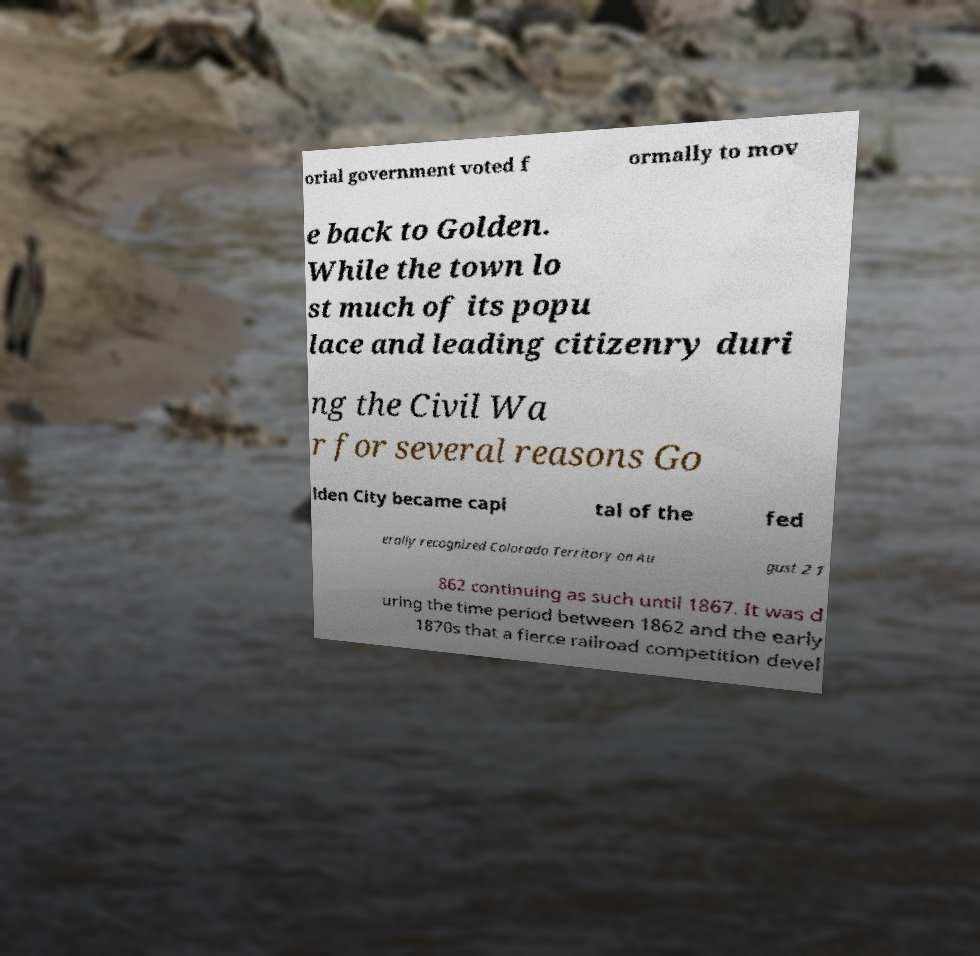Please read and relay the text visible in this image. What does it say? orial government voted f ormally to mov e back to Golden. While the town lo st much of its popu lace and leading citizenry duri ng the Civil Wa r for several reasons Go lden City became capi tal of the fed erally recognized Colorado Territory on Au gust 2 1 862 continuing as such until 1867. It was d uring the time period between 1862 and the early 1870s that a fierce railroad competition devel 